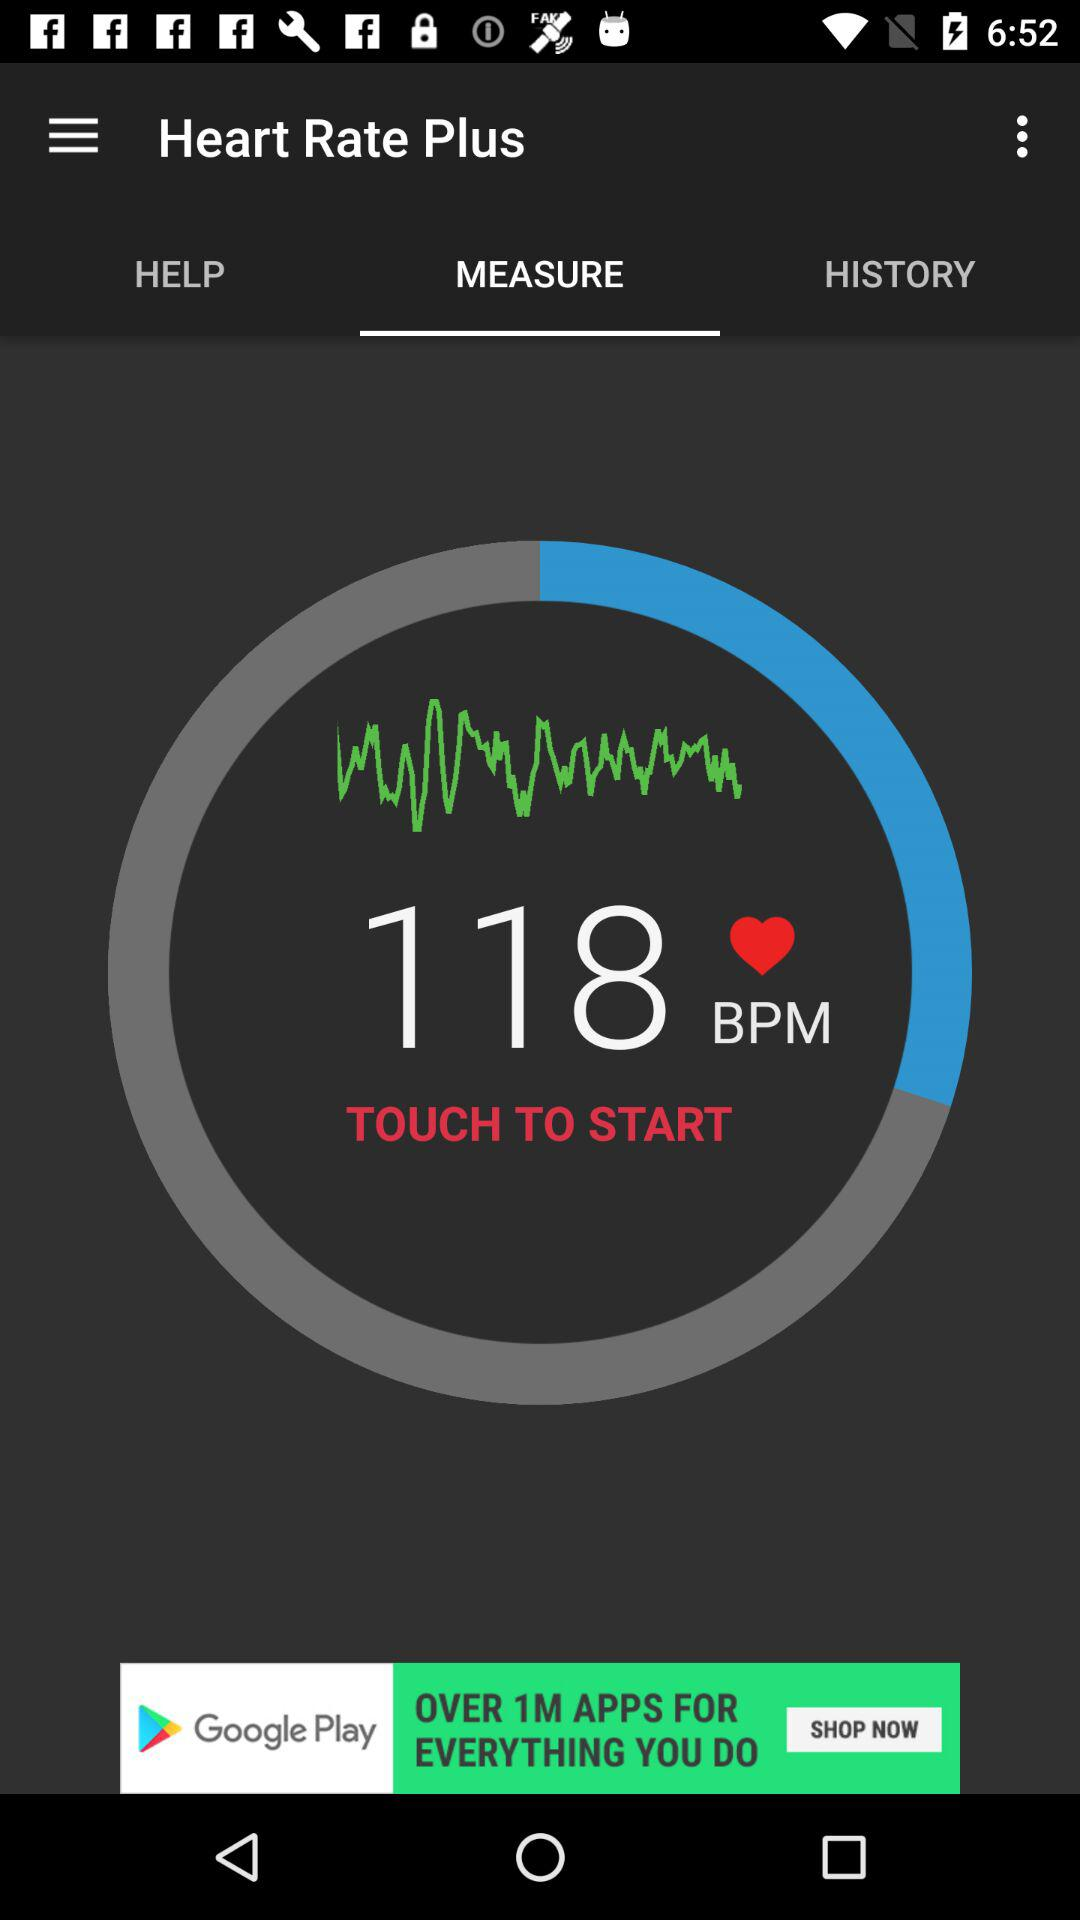Which tab is selected? The selected tab is "MEASURE". 